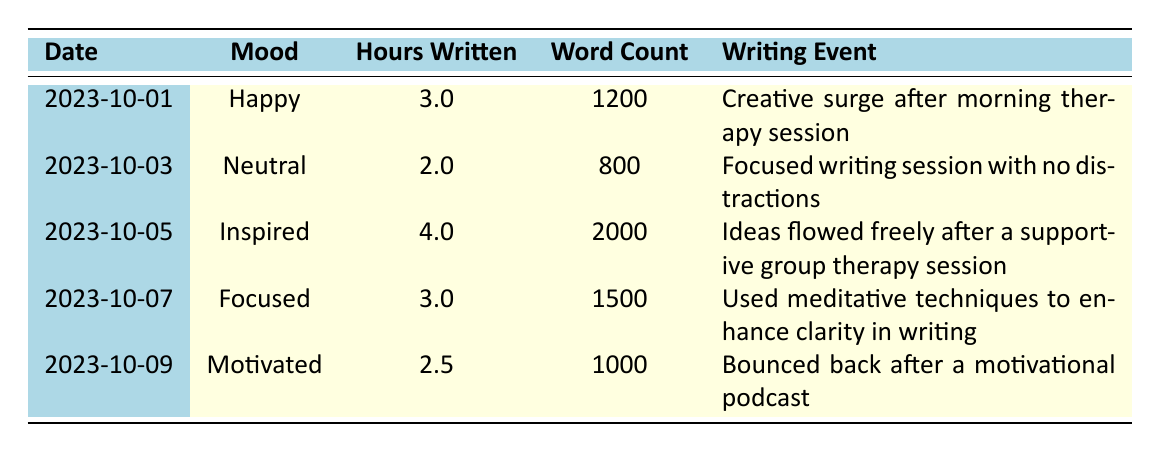What mood was recorded on 2023-10-05? The table indicates that on 2023-10-05, the mood was "Inspired".
Answer: Inspired How many hours were written on the day with the "Happy" mood? According to the table, on the day with the "Happy" mood (2023-10-01), there were 3 hours written.
Answer: 3 What was the total word count across all entries with a "Focused" mood? There is one entry with a "Focused" mood on 2023-10-07, which has a word count of 1500. Thus, the total word count is 1500.
Answer: 1500 What is the average number of hours written when the mood is "Anxious"? There is one entry for "Anxious" on 2023-10-02, which has 1.5 hours written. Since there's only one data point, the average is 1.5 hours.
Answer: 1.5 Which mood had the highest word count, and how much was it? The highest word count is 2000, which corresponds to the mood "Inspired" on 2023-10-05.
Answer: Inspired, 2000 Did the writer write any words on 2023-10-08? On 2023-10-08, the entry shows that the writer did not write at all, recorded as 0 word count.
Answer: No What is the difference in hours written on days where the mood was "Sad" and "Motivated"? The "Sad" mood on 2023-10-04 corresponds to 0.5 hours written, while the "Motivated" mood on 2023-10-09 corresponds to 2.5 hours written. The difference is 2.5 - 0.5 = 2.0 hours.
Answer: 2.0 How many total hours were written on days with a positive mood (Happy, Inspired, Motivated)? The total hours for positive moods are: Happy (3) + Inspired (4) + Motivated (2.5) = 9.5 hours.
Answer: 9.5 Was there a case where the writer worked for zero hours and what was the mood? Yes, on 2023-10-08, the writer recorded zero writing hours, and the mood was "Overwhelmed".
Answer: Yes, Overwhelmed Considering the mood data, on which day was the highest word count achieved, and what was the corresponding mood? The highest word count of 2000 was achieved on 2023-10-05, and the corresponding mood was "Inspired".
Answer: 2023-10-05, Inspired 